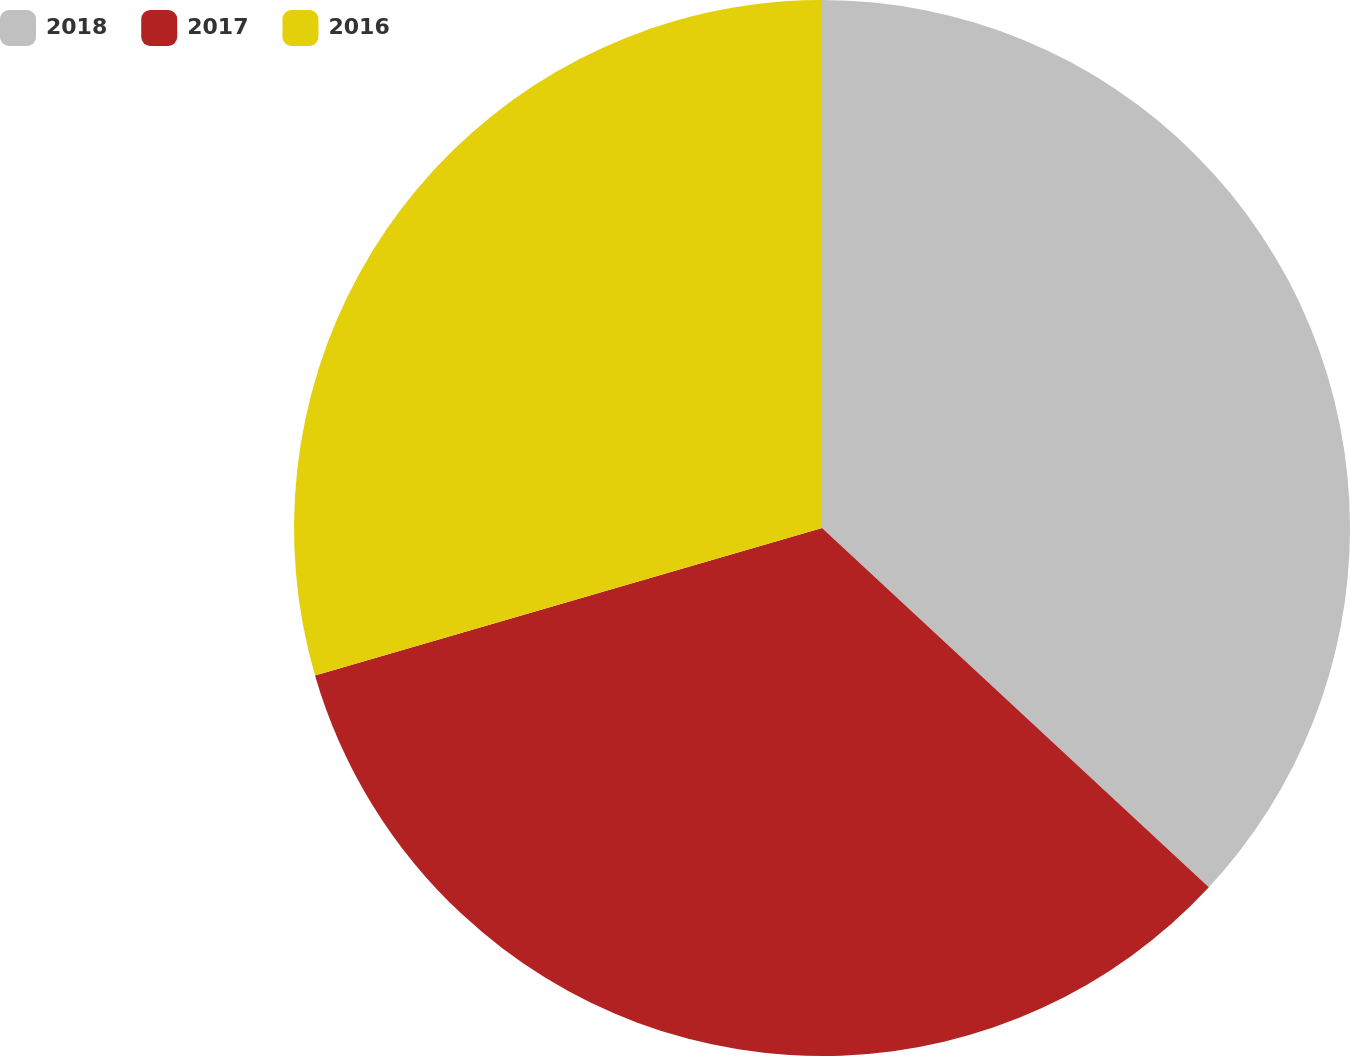Convert chart. <chart><loc_0><loc_0><loc_500><loc_500><pie_chart><fcel>2018<fcel>2017<fcel>2016<nl><fcel>36.91%<fcel>33.58%<fcel>29.5%<nl></chart> 